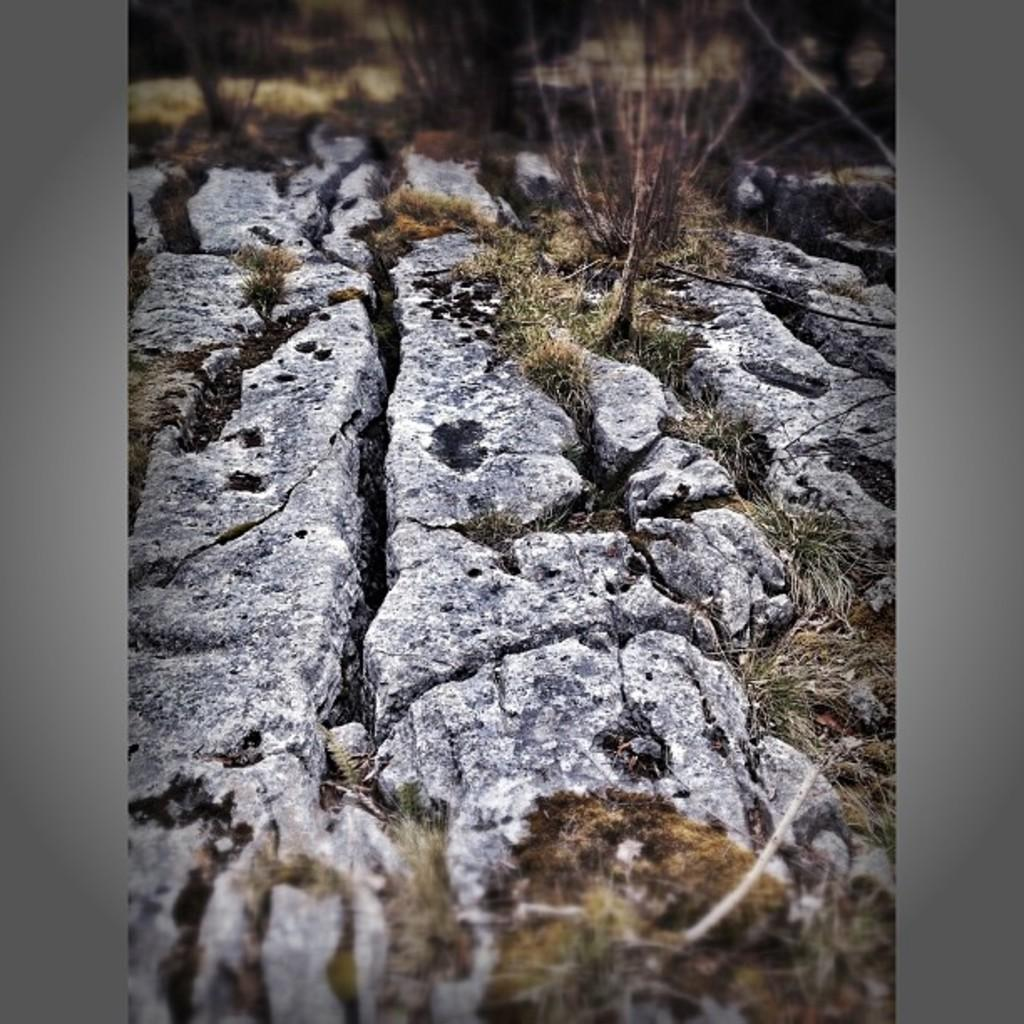What is located at the bottom of the image? There is a walkway at the bottom of the image. What type of vegetation is near the walkway? There is grass near the walkway. What can be seen in the background of the image? There are plants and grass visible in the background of the image. How many pies are being shared between the couple in the image? There is no couple or pie present in the image. 